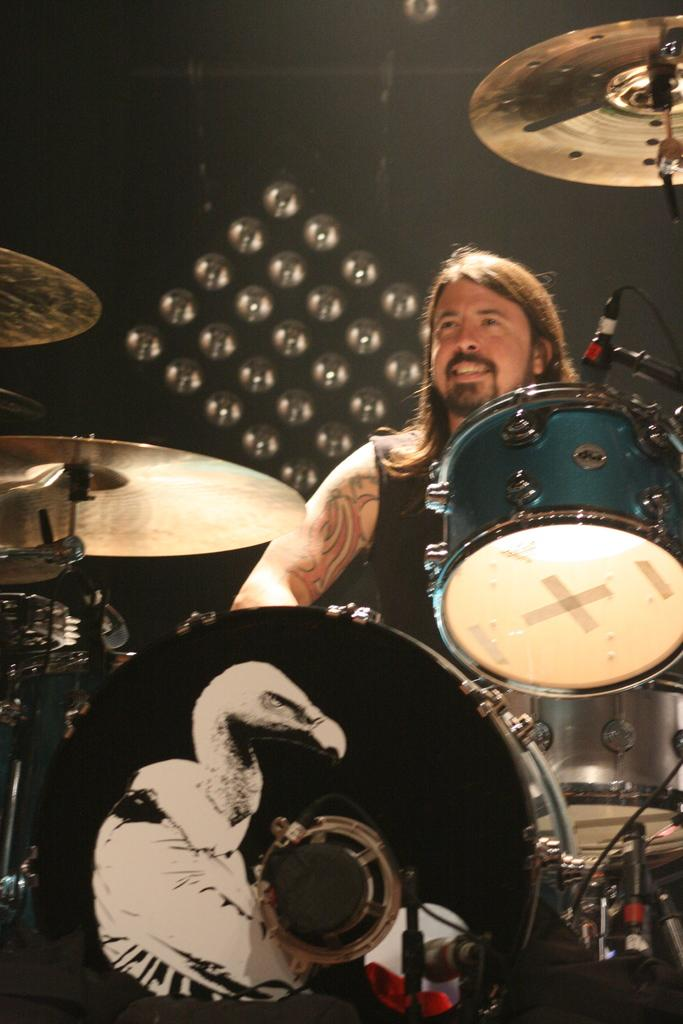What is the main subject of the image? The main subject of the image is a man. What is the man doing in the image? The man is playing musical drums in the image. What type of silk fabric is being used to make the man's trousers in the image? There is no mention of trousers or silk fabric in the image, so it cannot be determined from the image. 